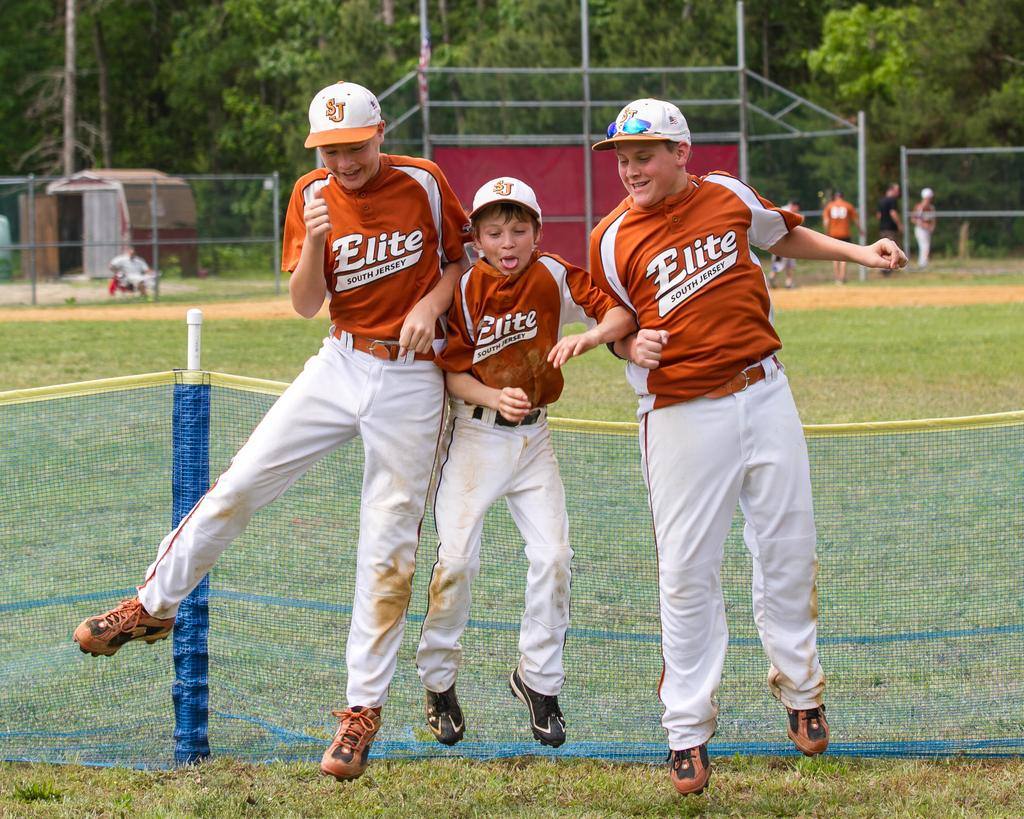<image>
Render a clear and concise summary of the photo. Three players from the Elite South Jersey baseball team are jumping and smiling. 